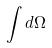Convert formula to latex. <formula><loc_0><loc_0><loc_500><loc_500>\int d \Omega</formula> 